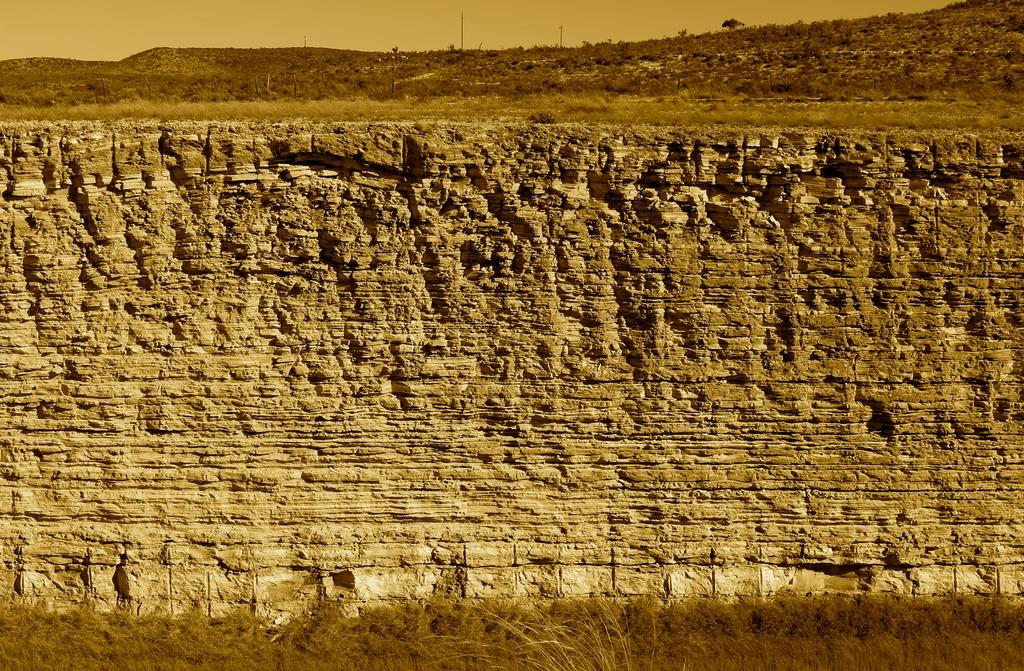What type of structure can be seen in the image? There is a wall in the image. What type of vegetation is present in the image? There is grass in the image. What type of plant is visible in the image? There is a tree in the image. What type of vertical structures can be seen in the image? There are poles in the image. What part of the natural environment is visible in the image? The sky is visible in the image. Can you tell me how much sugar is on the tree in the image? There is no sugar present on the tree in the image; it is a natural tree with leaves and branches. What type of shop can be seen in the image? There is no shop present in the image; it features a wall, grass, a tree, poles, and the sky. 